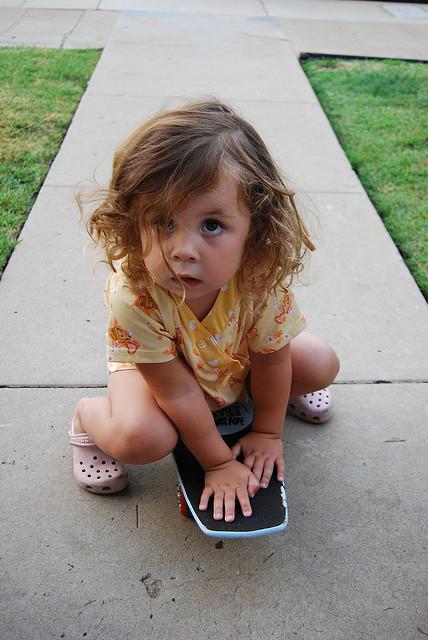Is she on the sidewalk?
Quick response, please. Yes. What color are the girl's shoes?
Short answer required. Pink. Is this kid eating a doughnut?
Write a very short answer. No. Is the baby wearing shoes?
Write a very short answer. Yes. Did somebody help this girl fix her hair?
Answer briefly. Yes. What is she sitting on?
Short answer required. Skateboard. 